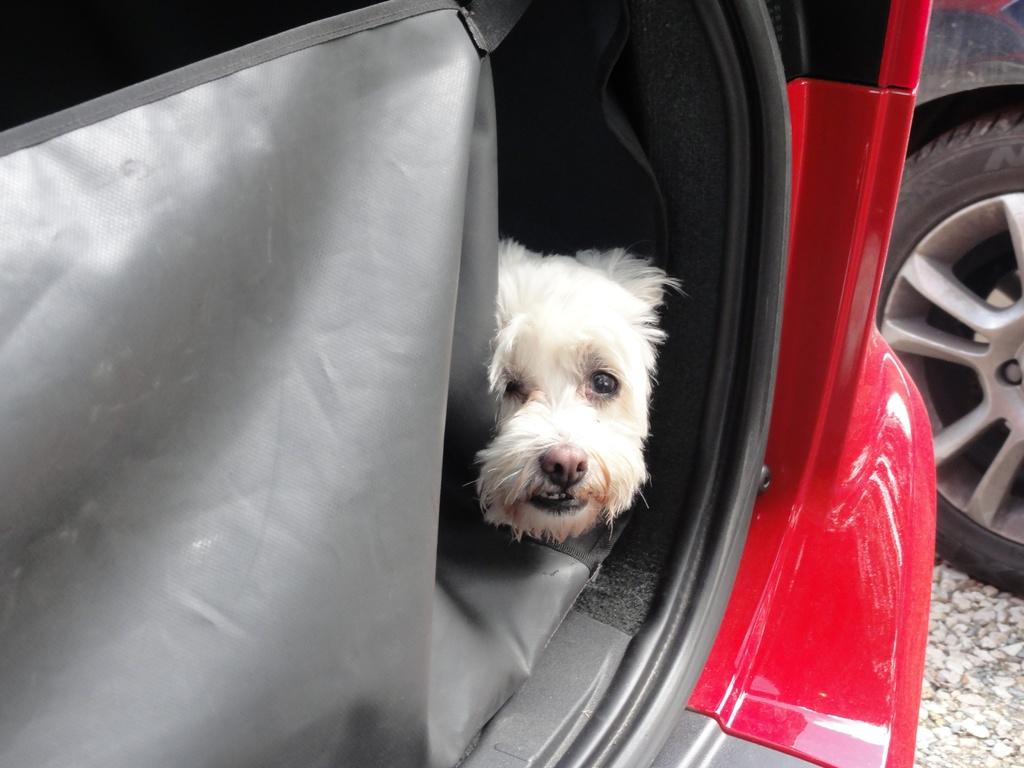What animal can be seen in the image? There is a dog in the image. Where is the dog located? The dog is in a vehicle. What type of question is the dog asking in the image? There is no indication that the dog is asking a question in the image, as dogs do not have the ability to ask questions. 